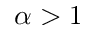Convert formula to latex. <formula><loc_0><loc_0><loc_500><loc_500>\alpha > 1</formula> 